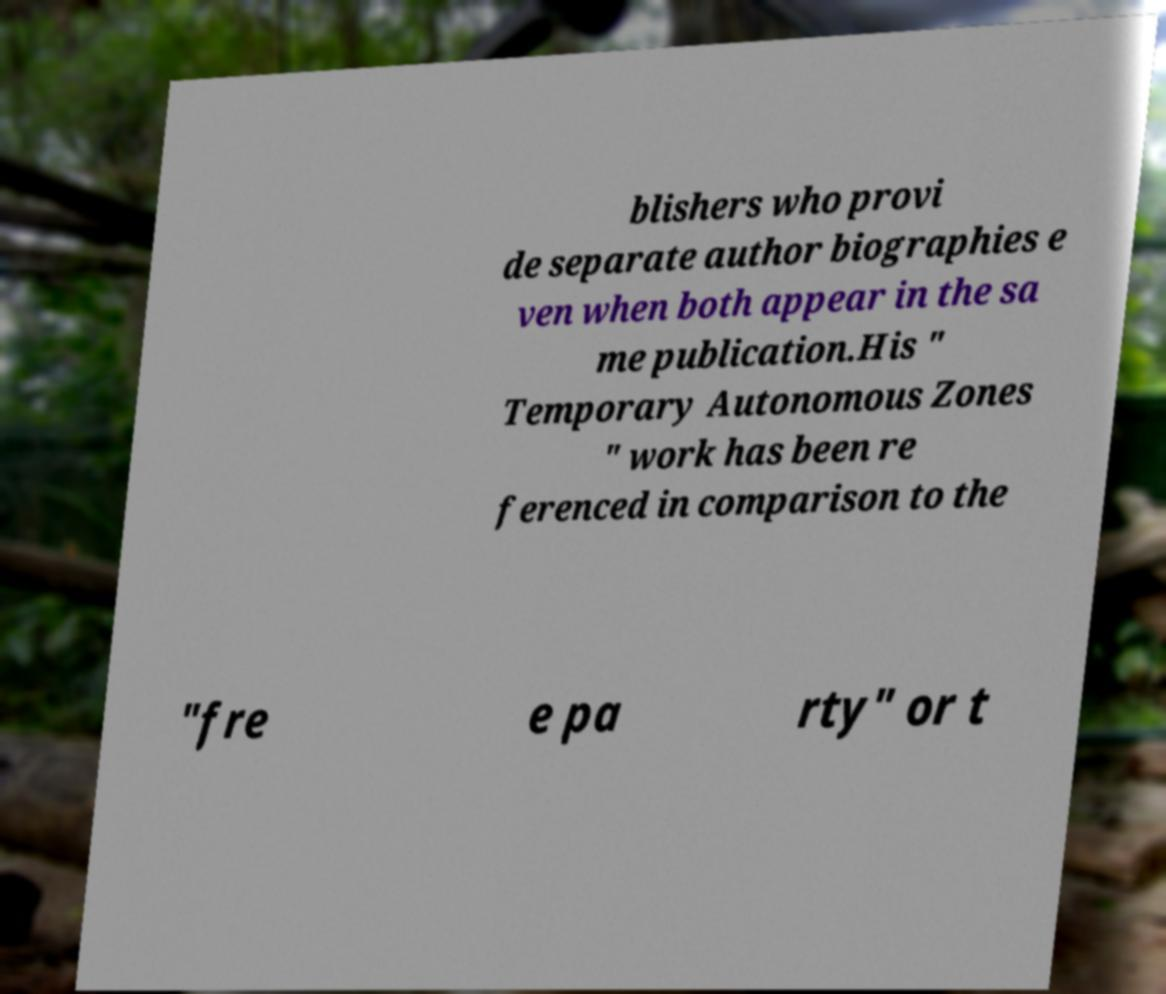What messages or text are displayed in this image? I need them in a readable, typed format. blishers who provi de separate author biographies e ven when both appear in the sa me publication.His " Temporary Autonomous Zones " work has been re ferenced in comparison to the "fre e pa rty" or t 